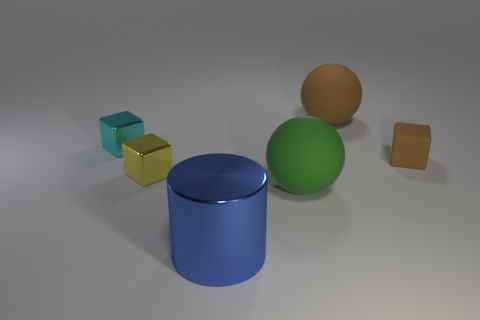Is the material of the large object that is behind the yellow cube the same as the cube that is behind the brown cube?
Offer a very short reply. No. Is the number of small yellow things less than the number of small gray things?
Provide a succinct answer. No. Is there a blue metal object right of the big rubber thing in front of the small block in front of the tiny brown rubber cube?
Your answer should be compact. No. How many rubber things are large brown spheres or purple cubes?
Keep it short and to the point. 1. There is a green matte sphere; how many big objects are behind it?
Offer a terse response. 1. What number of things are in front of the brown matte sphere and behind the cylinder?
Your response must be concise. 4. The small yellow object that is the same material as the blue cylinder is what shape?
Provide a short and direct response. Cube. There is a brown matte thing behind the cyan block; does it have the same size as the shiny cube behind the small brown rubber thing?
Provide a succinct answer. No. What color is the ball behind the big green matte sphere?
Make the answer very short. Brown. What material is the small block right of the large blue shiny thing that is in front of the small cyan object made of?
Offer a terse response. Rubber. 